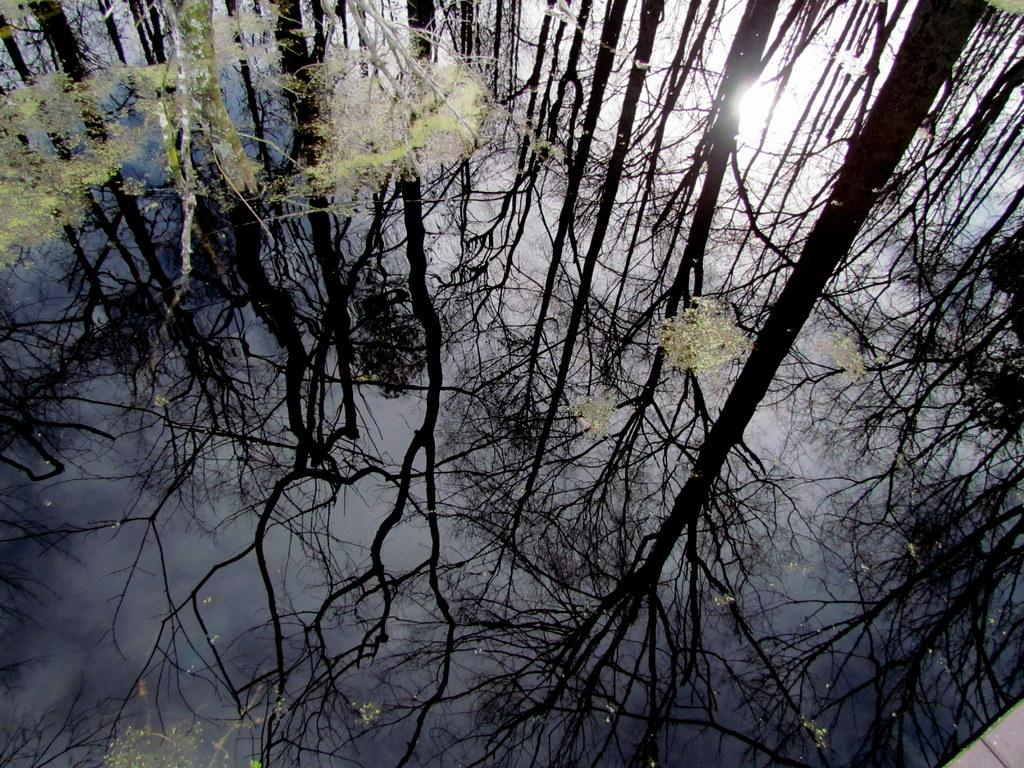What is the primary element in the image? There is water in the image. What can be seen floating on the water? There are objects floating on the water. What is reflected in the water? The reflection of trees and the sky is visible in the water. Can you see an island in the image? There is no mention of an island in the image. 